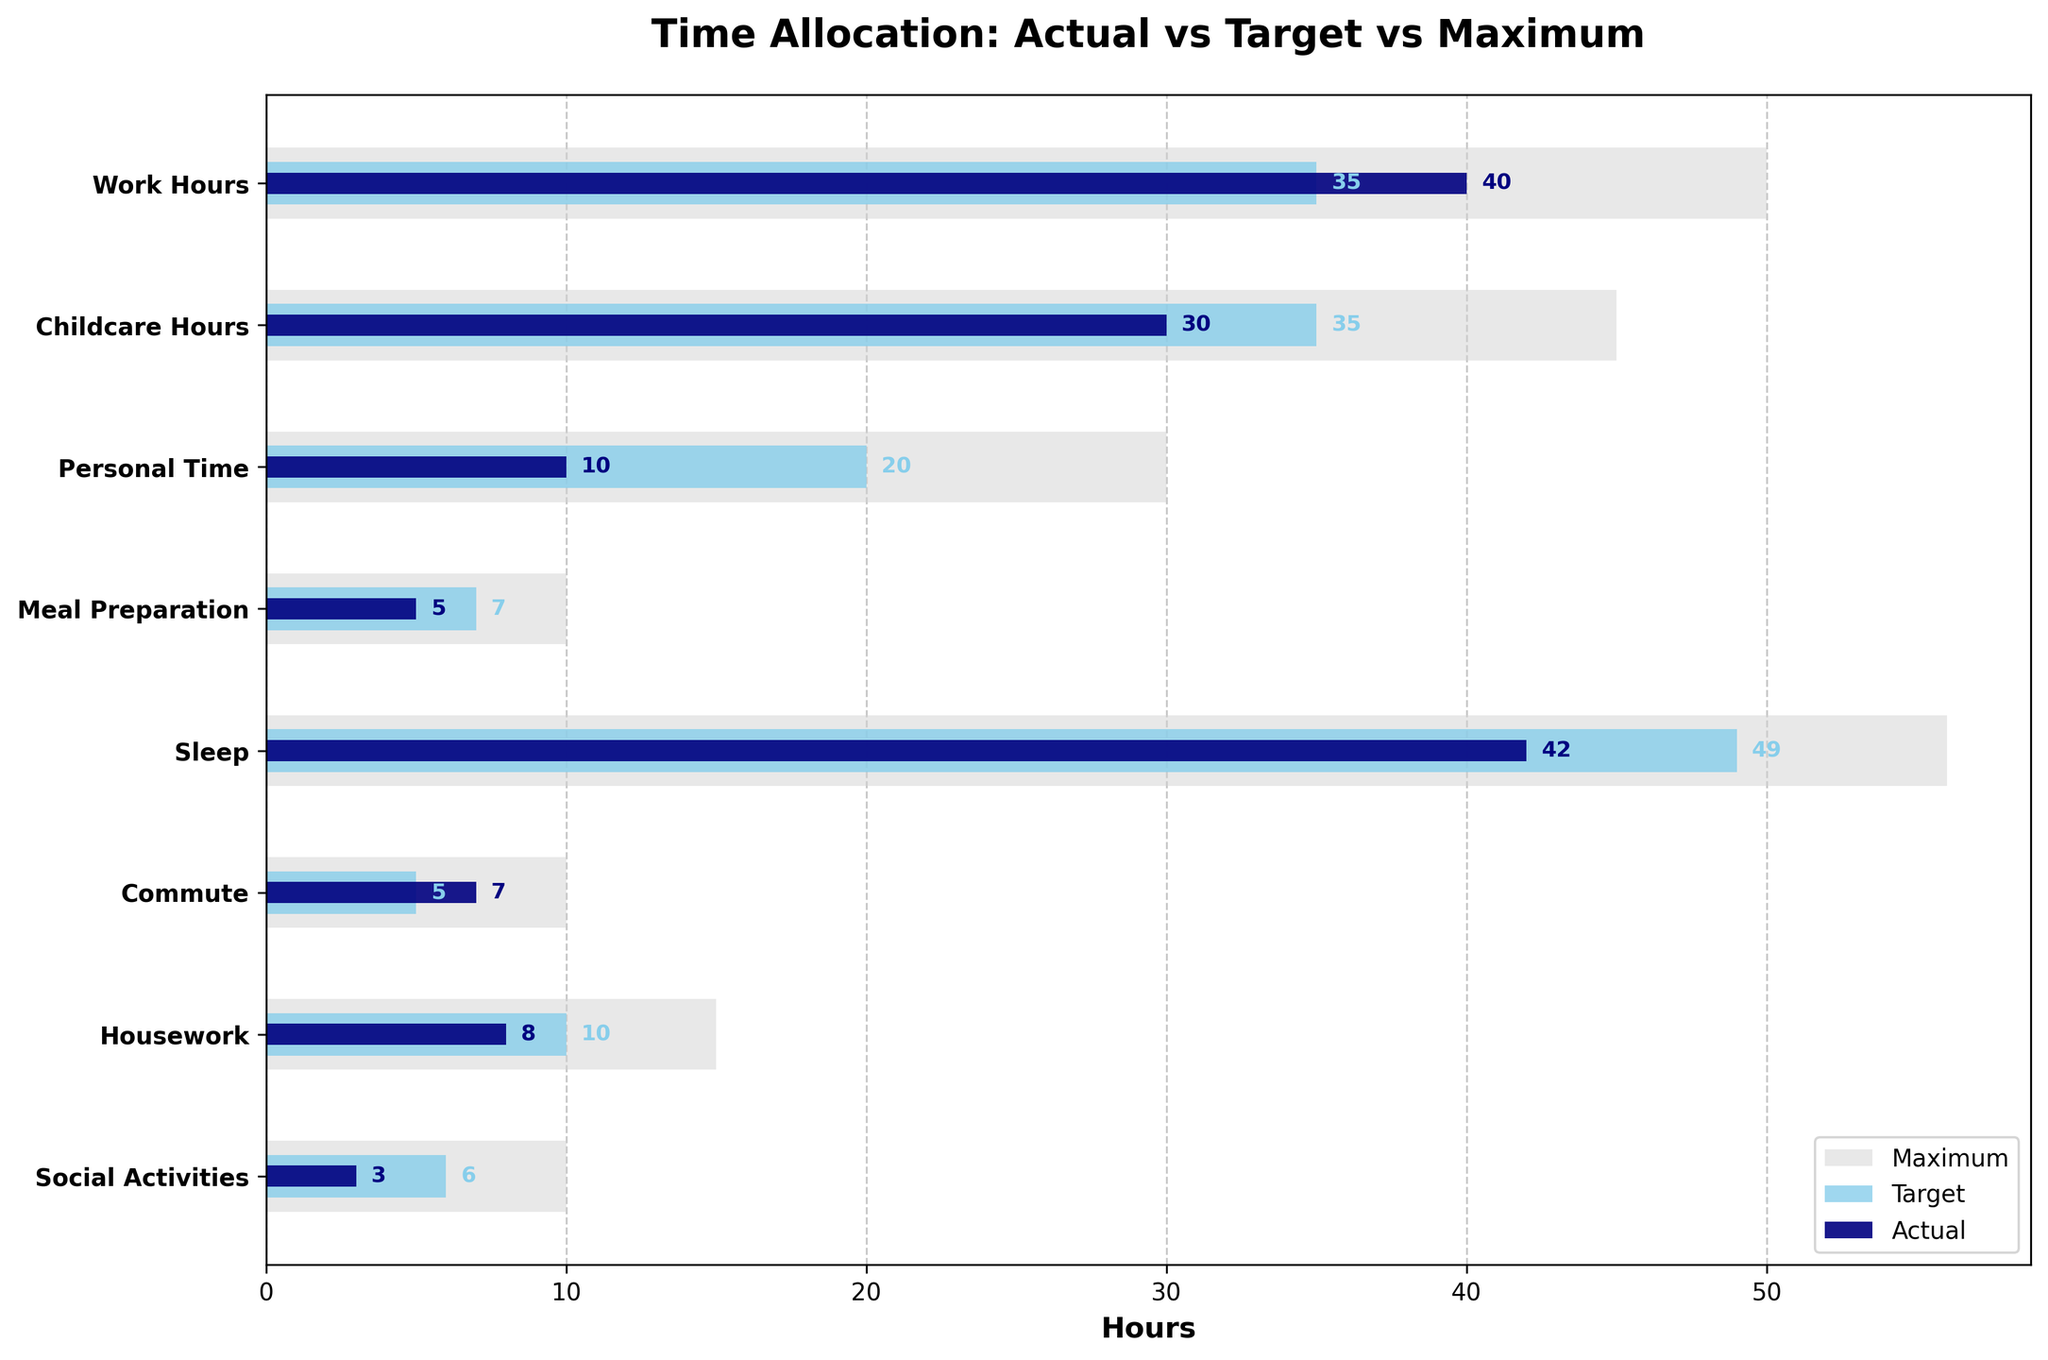What is the total number of hours allocated for Sleep? The figure shows Sleep has an "Actual" value of 42 hours.
Answer: 42 How does the actual time spent on Personal Time compare to its target? The actual time spent on Personal Time is 10 hours while the target is 20 hours. To find the difference: 20 - 10 = 10 hours. Thus, the actual time is 10 hours less than the target.
Answer: 10 hours less Which category has the highest maximum value? The Sleep category has a maximum value of 56 hours, which is the highest among all categories.
Answer: Sleep What is the difference between the actual and target hours for Work Hours? The actual Work Hours are 40 hours, and the target is 35 hours. The difference is 40 - 35 = 5 hours.
Answer: 5 hours What percentage of the target is the actual time spent on Housework? The actual time spent on Housework is 8 hours, and the target is 10 hours. Percentage = (8/10) * 100 = 80%.
Answer: 80% Which category exceeds its target by the highest amount? The Commute category exceeds its target by 2 hours (7 actual - 5 target), which is the highest excess amount among all categories.
Answer: Commute How much less time is spent on Meal Preparation compared to Social Activities? The actual time for Meal Preparation is 5 hours, whereas for Social Activities, it is 3 hours. The difference is 5 - 3 = 2 hours.
Answer: 2 hours more What is the overall deviation from targets across all categories? Calculate the deviation for each category: Work Hours = 40 - 35 = 5, Childcare Hours = 30 - 35 = -5, Personal Time = 10 - 20 = -10, Meal Preparation = 5 - 7 = -2, Sleep = 42 - 49 = -7, Commute = 7 - 5 = 2, Housework = 8 - 10 = -2, Social Activities = 3 - 6 = -3. Summing these deviations gives: 5 - 5 - 10 - 2 - 7 + 2 - 2 - 3 = -22 hours.
Answer: -22 hours Which two activities have the smallest difference in actual hours? From the figure, Personal Time (10 hours) and Housework (8 hours) have a difference of 2 hours, which is the smallest difference among all categories.
Answer: Personal Time and Housework What is the total actual time spent on Work Hours, Childcare Hours, and Personal Time combined? Adding the actual times: Work Hours = 40, Childcare Hours = 30, Personal Time = 10, total = 40 + 30 + 10 = 80 hours.
Answer: 80 hours 